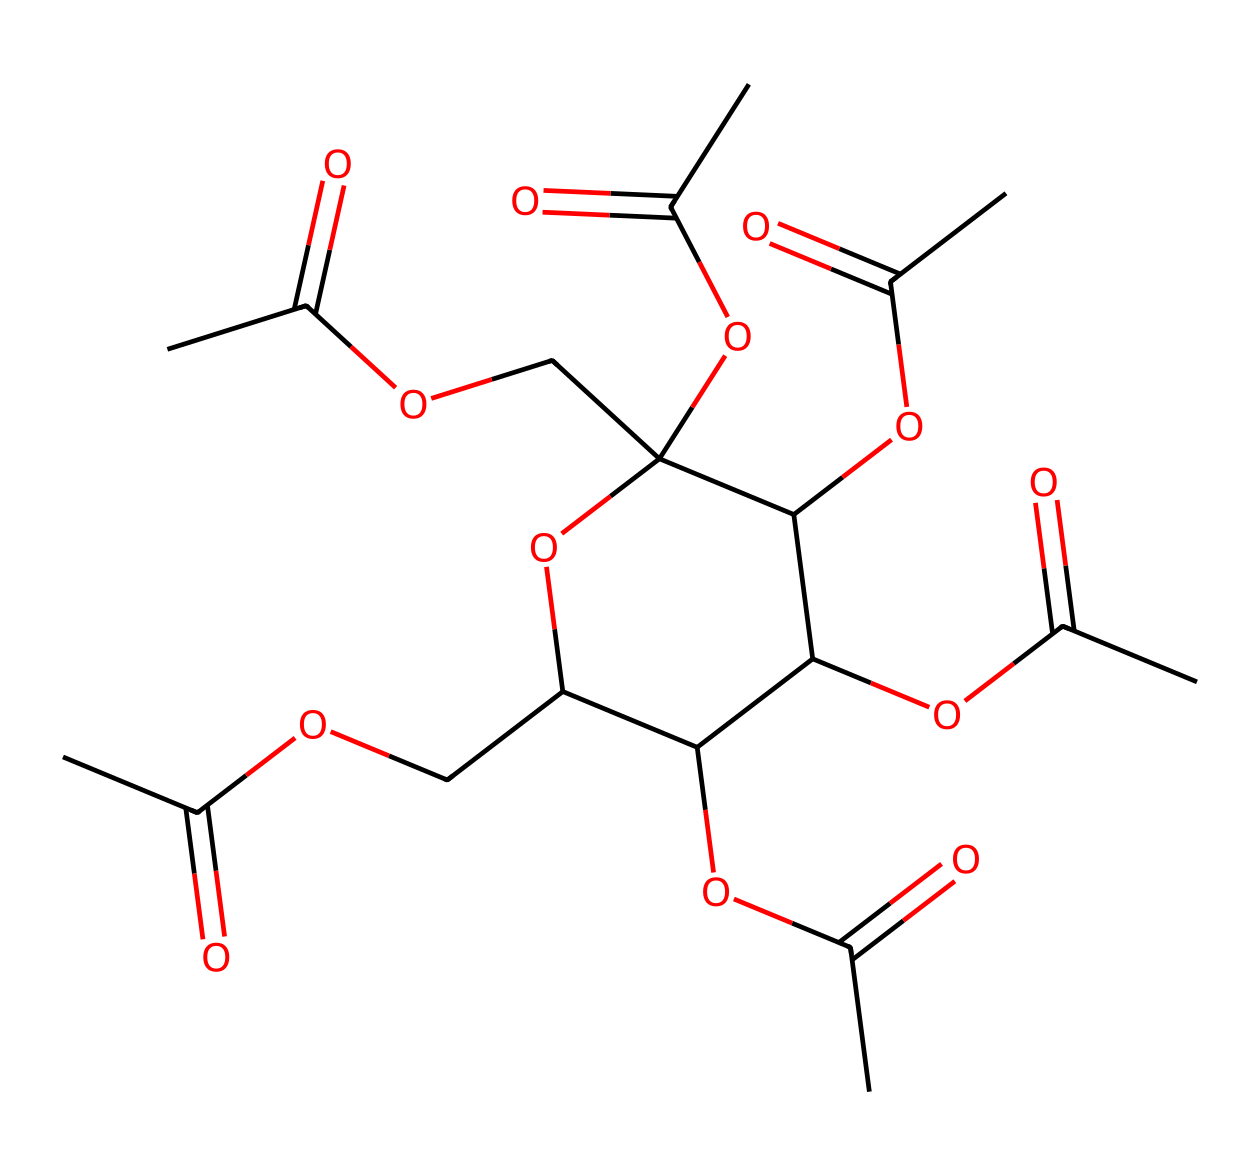What is the chemical name of this structure? The SMILES representation corresponds to cellulose acetate, which is derived from cellulose through acetylation, where hydroxyl groups are replaced by acetate groups.
Answer: cellulose acetate How many carbon atoms are in this molecule? To find the number of carbon atoms, count each "C" in the SMILES notation. By examining the structure represented, there are 10 carbon atoms present in this chemical.
Answer: 10 What functional groups are present in this compound? The SMILES indicates the presence of acetyl groups (indicated by the "CC(=O)"), as well as ether linkages (shown by "OCC"). These functional groups are typical for cellulose acetate.
Answer: acetyl and ether How many acetate groups are in this structure? The "C(=O)O" segments in the SMILES indicate acetyl groups. By counting these segments, it is clear there are 5 acetate groups present in the structure.
Answer: 5 Is this compound polar or nonpolar? The presence of multiple polar functional groups (acetyl and ether) indicates that cellulose acetate is polar, which influences its solubility and interaction with water.
Answer: polar What type of polymer is cellulose acetate considered? Cellulose acetate is considered a thermoplastic polymer due to its properties of being moldable and recyclable when heated, which is characteristic of thermoplastic materials.
Answer: thermoplastic 